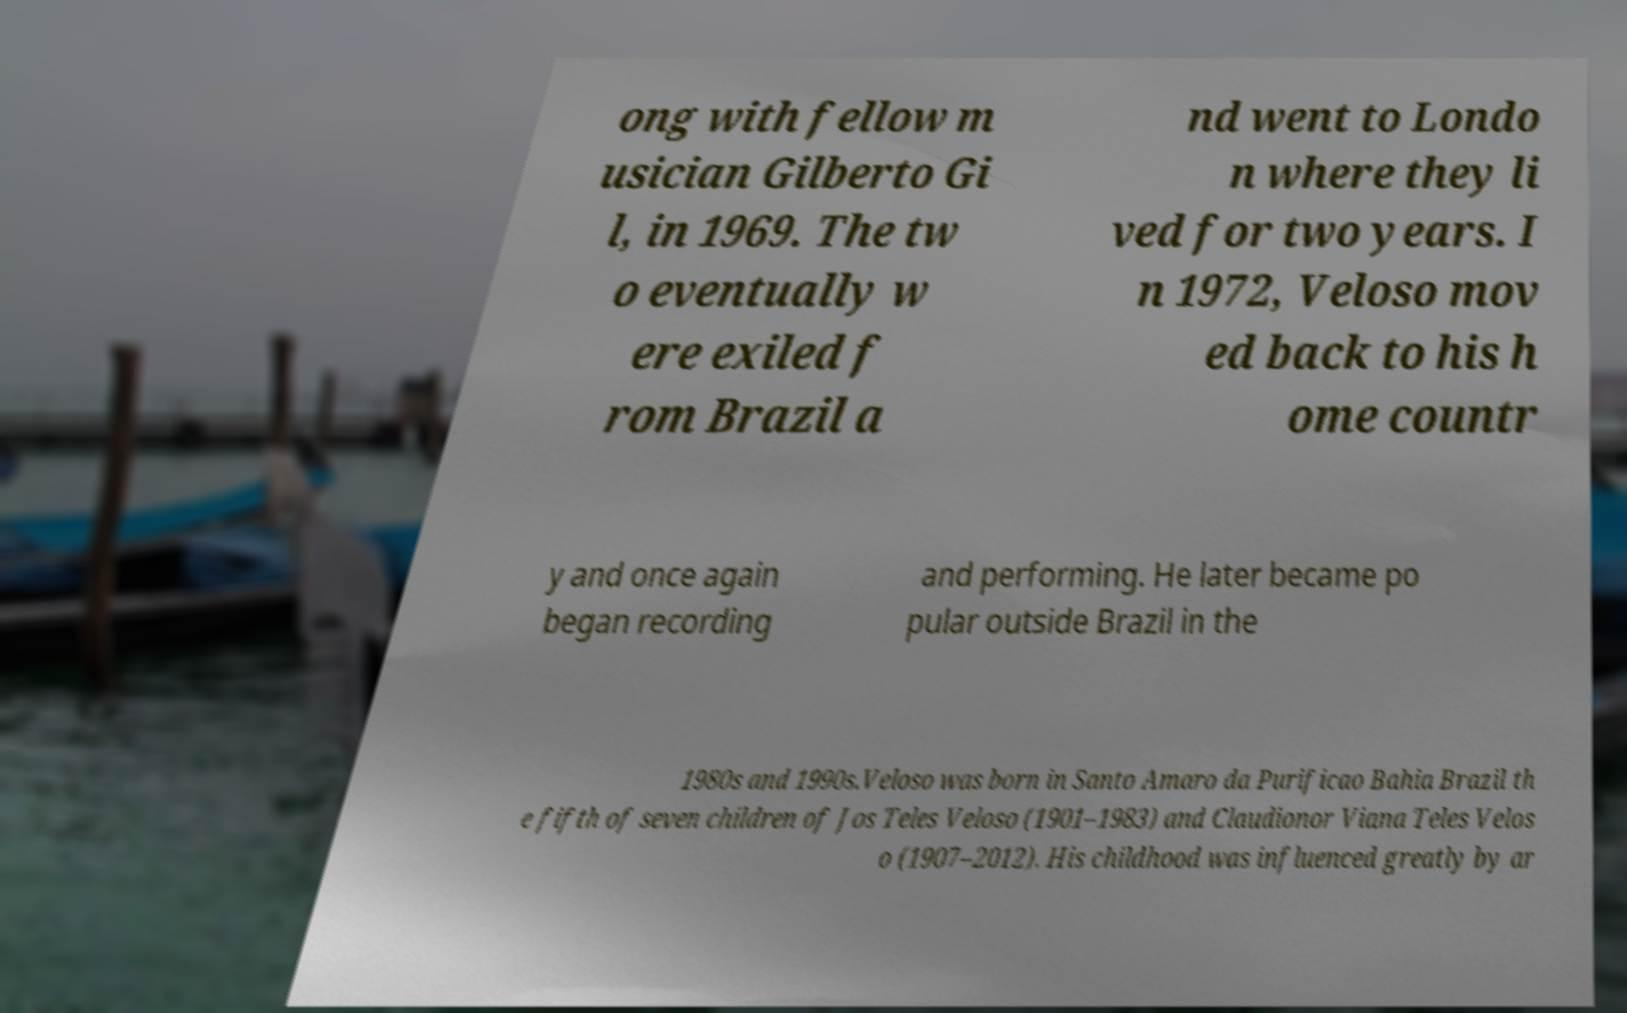Please identify and transcribe the text found in this image. ong with fellow m usician Gilberto Gi l, in 1969. The tw o eventually w ere exiled f rom Brazil a nd went to Londo n where they li ved for two years. I n 1972, Veloso mov ed back to his h ome countr y and once again began recording and performing. He later became po pular outside Brazil in the 1980s and 1990s.Veloso was born in Santo Amaro da Purificao Bahia Brazil th e fifth of seven children of Jos Teles Veloso (1901–1983) and Claudionor Viana Teles Velos o (1907–2012). His childhood was influenced greatly by ar 